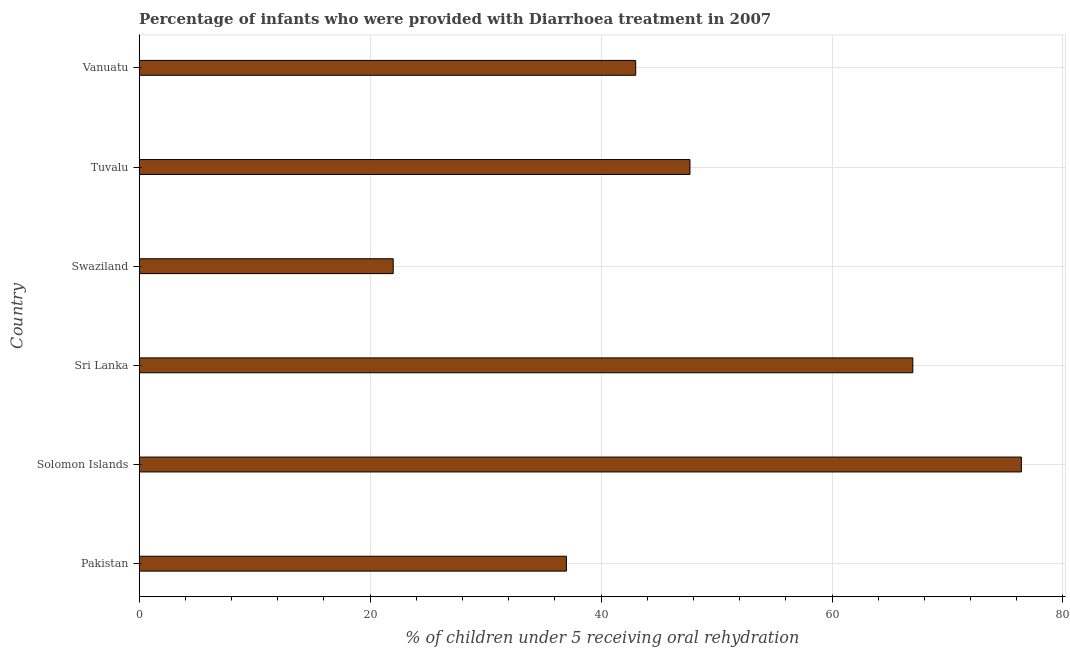What is the title of the graph?
Provide a short and direct response. Percentage of infants who were provided with Diarrhoea treatment in 2007. What is the label or title of the X-axis?
Your answer should be very brief. % of children under 5 receiving oral rehydration. What is the label or title of the Y-axis?
Give a very brief answer. Country. What is the percentage of children who were provided with treatment diarrhoea in Tuvalu?
Provide a short and direct response. 47.7. Across all countries, what is the maximum percentage of children who were provided with treatment diarrhoea?
Provide a short and direct response. 76.4. Across all countries, what is the minimum percentage of children who were provided with treatment diarrhoea?
Your answer should be compact. 22. In which country was the percentage of children who were provided with treatment diarrhoea maximum?
Make the answer very short. Solomon Islands. In which country was the percentage of children who were provided with treatment diarrhoea minimum?
Your response must be concise. Swaziland. What is the sum of the percentage of children who were provided with treatment diarrhoea?
Your response must be concise. 293.1. What is the average percentage of children who were provided with treatment diarrhoea per country?
Your answer should be very brief. 48.85. What is the median percentage of children who were provided with treatment diarrhoea?
Your answer should be very brief. 45.35. In how many countries, is the percentage of children who were provided with treatment diarrhoea greater than 20 %?
Give a very brief answer. 6. What is the ratio of the percentage of children who were provided with treatment diarrhoea in Sri Lanka to that in Tuvalu?
Offer a terse response. 1.41. What is the difference between the highest and the lowest percentage of children who were provided with treatment diarrhoea?
Offer a terse response. 54.4. In how many countries, is the percentage of children who were provided with treatment diarrhoea greater than the average percentage of children who were provided with treatment diarrhoea taken over all countries?
Give a very brief answer. 2. How many bars are there?
Your answer should be compact. 6. How many countries are there in the graph?
Offer a very short reply. 6. Are the values on the major ticks of X-axis written in scientific E-notation?
Make the answer very short. No. What is the % of children under 5 receiving oral rehydration in Solomon Islands?
Give a very brief answer. 76.4. What is the % of children under 5 receiving oral rehydration in Sri Lanka?
Give a very brief answer. 67. What is the % of children under 5 receiving oral rehydration in Swaziland?
Your answer should be compact. 22. What is the % of children under 5 receiving oral rehydration in Tuvalu?
Your response must be concise. 47.7. What is the difference between the % of children under 5 receiving oral rehydration in Pakistan and Solomon Islands?
Keep it short and to the point. -39.4. What is the difference between the % of children under 5 receiving oral rehydration in Pakistan and Sri Lanka?
Provide a succinct answer. -30. What is the difference between the % of children under 5 receiving oral rehydration in Pakistan and Swaziland?
Your response must be concise. 15. What is the difference between the % of children under 5 receiving oral rehydration in Pakistan and Tuvalu?
Your answer should be very brief. -10.7. What is the difference between the % of children under 5 receiving oral rehydration in Pakistan and Vanuatu?
Your answer should be very brief. -6. What is the difference between the % of children under 5 receiving oral rehydration in Solomon Islands and Swaziland?
Make the answer very short. 54.4. What is the difference between the % of children under 5 receiving oral rehydration in Solomon Islands and Tuvalu?
Offer a terse response. 28.7. What is the difference between the % of children under 5 receiving oral rehydration in Solomon Islands and Vanuatu?
Give a very brief answer. 33.4. What is the difference between the % of children under 5 receiving oral rehydration in Sri Lanka and Swaziland?
Your response must be concise. 45. What is the difference between the % of children under 5 receiving oral rehydration in Sri Lanka and Tuvalu?
Your answer should be compact. 19.3. What is the difference between the % of children under 5 receiving oral rehydration in Swaziland and Tuvalu?
Your answer should be compact. -25.7. What is the difference between the % of children under 5 receiving oral rehydration in Swaziland and Vanuatu?
Give a very brief answer. -21. What is the ratio of the % of children under 5 receiving oral rehydration in Pakistan to that in Solomon Islands?
Give a very brief answer. 0.48. What is the ratio of the % of children under 5 receiving oral rehydration in Pakistan to that in Sri Lanka?
Your response must be concise. 0.55. What is the ratio of the % of children under 5 receiving oral rehydration in Pakistan to that in Swaziland?
Ensure brevity in your answer.  1.68. What is the ratio of the % of children under 5 receiving oral rehydration in Pakistan to that in Tuvalu?
Give a very brief answer. 0.78. What is the ratio of the % of children under 5 receiving oral rehydration in Pakistan to that in Vanuatu?
Keep it short and to the point. 0.86. What is the ratio of the % of children under 5 receiving oral rehydration in Solomon Islands to that in Sri Lanka?
Offer a very short reply. 1.14. What is the ratio of the % of children under 5 receiving oral rehydration in Solomon Islands to that in Swaziland?
Ensure brevity in your answer.  3.47. What is the ratio of the % of children under 5 receiving oral rehydration in Solomon Islands to that in Tuvalu?
Your answer should be compact. 1.6. What is the ratio of the % of children under 5 receiving oral rehydration in Solomon Islands to that in Vanuatu?
Your answer should be compact. 1.78. What is the ratio of the % of children under 5 receiving oral rehydration in Sri Lanka to that in Swaziland?
Your response must be concise. 3.04. What is the ratio of the % of children under 5 receiving oral rehydration in Sri Lanka to that in Tuvalu?
Offer a terse response. 1.41. What is the ratio of the % of children under 5 receiving oral rehydration in Sri Lanka to that in Vanuatu?
Make the answer very short. 1.56. What is the ratio of the % of children under 5 receiving oral rehydration in Swaziland to that in Tuvalu?
Your response must be concise. 0.46. What is the ratio of the % of children under 5 receiving oral rehydration in Swaziland to that in Vanuatu?
Your answer should be compact. 0.51. What is the ratio of the % of children under 5 receiving oral rehydration in Tuvalu to that in Vanuatu?
Your answer should be very brief. 1.11. 